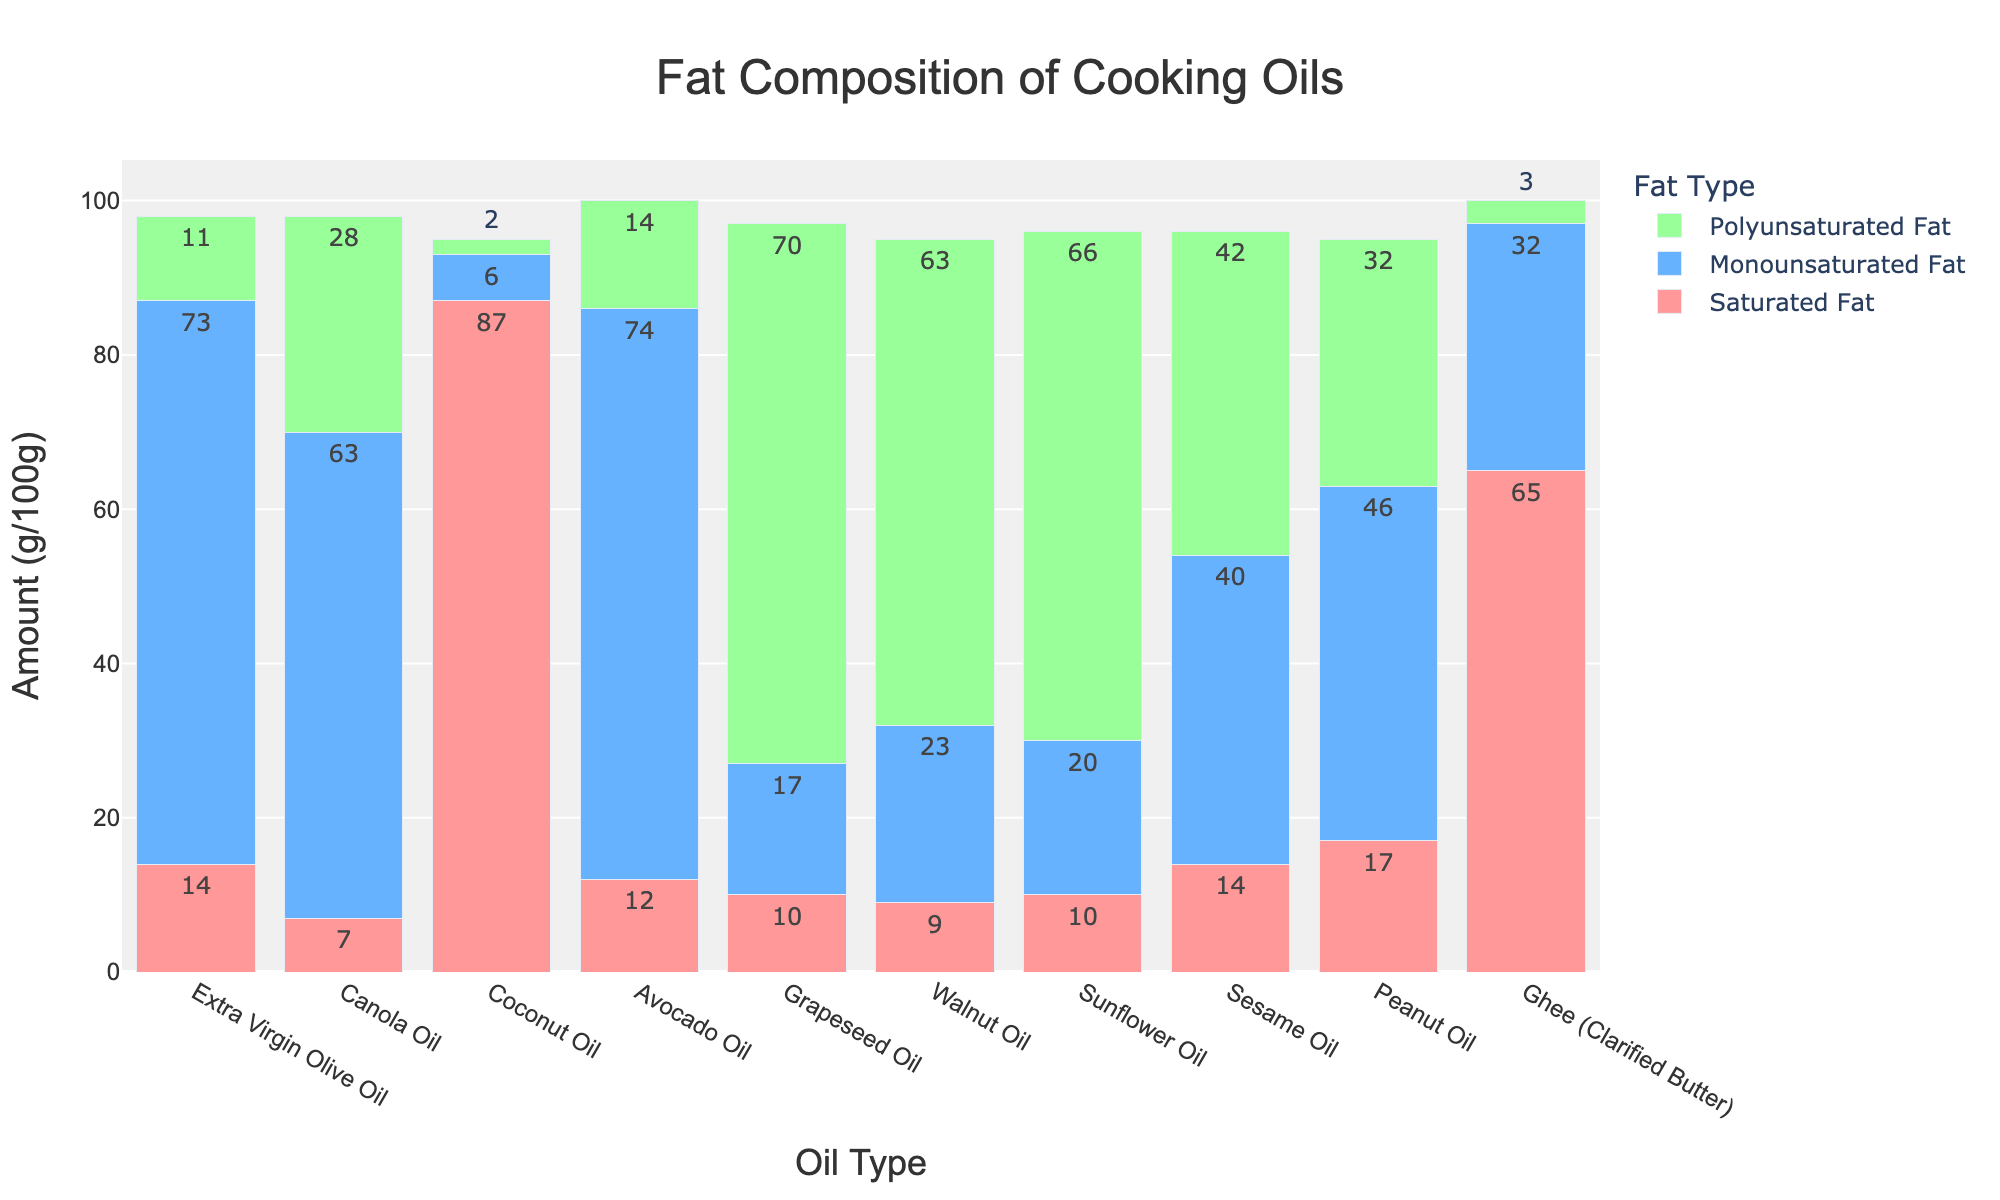What's the oil with the highest amount of saturated fat? Look for the bar representing the saturated fat that reaches the highest point on the y-axis. Coconut Oil has the tallest red bar among all oil types for saturated fat.
Answer: Coconut Oil Which oil has the most monounsaturated fat? Identify the tallest blue bar in the graph, which indicates the highest amount of monounsaturated fat. Avocado Oil has the highest blue bar among all oil types.
Answer: Avocado Oil How does the polyunsaturated fat in Grapeseed Oil compare to that in Sesame Oil? Compare the heights of the green bars for both oils. The green bar for Grapeseed Oil is taller than that of Sesame Oil, indicating a higher polyunsaturated fat content.
Answer: Grapeseed Oil has more Which oil types have equal amounts of saturated fat? Look for bars labeled as saturated fat (red) of equal height. Extra Virgin Olive Oil and Sesame Oil both show the same height for their red bars, indicating equal amounts of saturated fat.
Answer: Extra Virgin Olive Oil and Sesame Oil What's the combined amount of saturated and monounsaturated fat in Peanut Oil? Identify the heights of the red and blue bars for Peanut Oil and sum their values. The red bar (saturated fat) is at 17, and the blue bar (monounsaturated fat) is at 46. Therefore, 17 + 46 = 63.
Answer: 63g/100g Is there any oil with exactly 20g/100g of monounsaturated fat? Look for a blue bar that aligns with the 20 value on the y-axis. Sunflower Oil has a blue bar exactly reaching the 20 mark.
Answer: Sunflower Oil Which oil has the smallest difference between monounsaturated fat and saturated fat? Calculate the difference for each oil by comparing the heights of the blue and red bars. Walnut Oil with monounsaturated fat of 23 and saturated fat of 9 has the smallest difference of 14.
Answer: Walnut Oil What is the ratio of polyunsaturated to saturated fat in Canola Oil? Find the height of the green and red bars for Canola Oil. The green bar (polyunsaturated fat) is at 28, and the red bar (saturated fat) is at 7. Therefore, the ratio is 28/7 = 4.
Answer: 4:1 Compare the monounsaturated fat content in Extra Virgin Olive Oil to Ghee. Which one has more? Compare the heights of the blue bars for both oils. Extra Virgin Olive Oil's blue bar is at 73, while Ghee's blue bar is at 32, indicating Extra Virgin Olive Oil has more.
Answer: Extra Virgin Olive Oil 